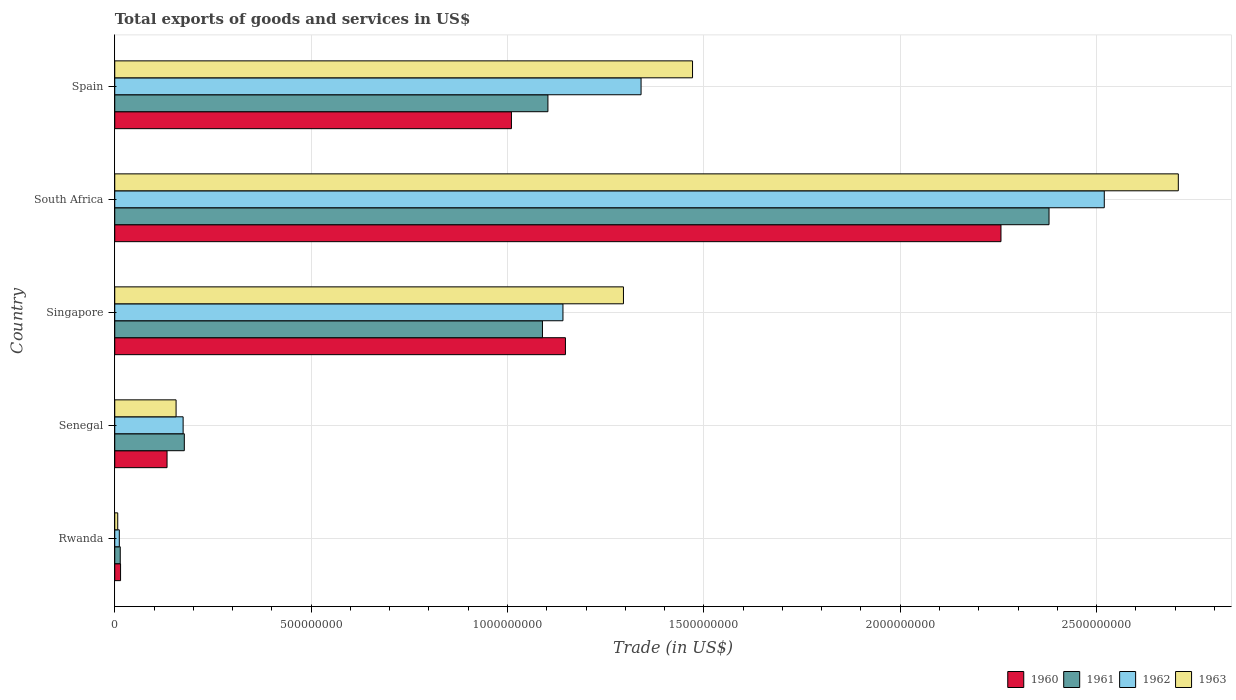How many bars are there on the 3rd tick from the top?
Give a very brief answer. 4. How many bars are there on the 1st tick from the bottom?
Provide a short and direct response. 4. What is the label of the 5th group of bars from the top?
Offer a terse response. Rwanda. What is the total exports of goods and services in 1960 in Rwanda?
Your response must be concise. 1.48e+07. Across all countries, what is the maximum total exports of goods and services in 1963?
Keep it short and to the point. 2.71e+09. Across all countries, what is the minimum total exports of goods and services in 1960?
Ensure brevity in your answer.  1.48e+07. In which country was the total exports of goods and services in 1962 maximum?
Your response must be concise. South Africa. In which country was the total exports of goods and services in 1963 minimum?
Offer a very short reply. Rwanda. What is the total total exports of goods and services in 1963 in the graph?
Provide a succinct answer. 5.64e+09. What is the difference between the total exports of goods and services in 1962 in Senegal and that in Spain?
Ensure brevity in your answer.  -1.17e+09. What is the difference between the total exports of goods and services in 1962 in Rwanda and the total exports of goods and services in 1960 in South Africa?
Ensure brevity in your answer.  -2.24e+09. What is the average total exports of goods and services in 1963 per country?
Give a very brief answer. 1.13e+09. What is the difference between the total exports of goods and services in 1960 and total exports of goods and services in 1962 in Spain?
Your response must be concise. -3.30e+08. In how many countries, is the total exports of goods and services in 1963 greater than 2600000000 US$?
Keep it short and to the point. 1. What is the ratio of the total exports of goods and services in 1962 in Singapore to that in Spain?
Your answer should be compact. 0.85. Is the total exports of goods and services in 1960 in Singapore less than that in South Africa?
Give a very brief answer. Yes. What is the difference between the highest and the second highest total exports of goods and services in 1962?
Ensure brevity in your answer.  1.18e+09. What is the difference between the highest and the lowest total exports of goods and services in 1963?
Keep it short and to the point. 2.70e+09. Is the sum of the total exports of goods and services in 1961 in Senegal and Spain greater than the maximum total exports of goods and services in 1960 across all countries?
Your response must be concise. No. Is it the case that in every country, the sum of the total exports of goods and services in 1962 and total exports of goods and services in 1960 is greater than the sum of total exports of goods and services in 1961 and total exports of goods and services in 1963?
Your answer should be very brief. No. What does the 4th bar from the top in Senegal represents?
Give a very brief answer. 1960. How many bars are there?
Your answer should be compact. 20. How many countries are there in the graph?
Your response must be concise. 5. What is the difference between two consecutive major ticks on the X-axis?
Your answer should be compact. 5.00e+08. Does the graph contain any zero values?
Make the answer very short. No. Where does the legend appear in the graph?
Provide a short and direct response. Bottom right. How many legend labels are there?
Offer a terse response. 4. What is the title of the graph?
Make the answer very short. Total exports of goods and services in US$. Does "1990" appear as one of the legend labels in the graph?
Offer a very short reply. No. What is the label or title of the X-axis?
Give a very brief answer. Trade (in US$). What is the label or title of the Y-axis?
Make the answer very short. Country. What is the Trade (in US$) of 1960 in Rwanda?
Your response must be concise. 1.48e+07. What is the Trade (in US$) in 1961 in Rwanda?
Your answer should be very brief. 1.40e+07. What is the Trade (in US$) in 1962 in Rwanda?
Offer a terse response. 1.16e+07. What is the Trade (in US$) in 1963 in Rwanda?
Offer a very short reply. 7.60e+06. What is the Trade (in US$) of 1960 in Senegal?
Give a very brief answer. 1.33e+08. What is the Trade (in US$) in 1961 in Senegal?
Offer a very short reply. 1.77e+08. What is the Trade (in US$) of 1962 in Senegal?
Keep it short and to the point. 1.74e+08. What is the Trade (in US$) in 1963 in Senegal?
Offer a very short reply. 1.56e+08. What is the Trade (in US$) in 1960 in Singapore?
Your answer should be very brief. 1.15e+09. What is the Trade (in US$) in 1961 in Singapore?
Your response must be concise. 1.09e+09. What is the Trade (in US$) in 1962 in Singapore?
Provide a succinct answer. 1.14e+09. What is the Trade (in US$) in 1963 in Singapore?
Keep it short and to the point. 1.30e+09. What is the Trade (in US$) in 1960 in South Africa?
Keep it short and to the point. 2.26e+09. What is the Trade (in US$) of 1961 in South Africa?
Ensure brevity in your answer.  2.38e+09. What is the Trade (in US$) in 1962 in South Africa?
Provide a succinct answer. 2.52e+09. What is the Trade (in US$) of 1963 in South Africa?
Keep it short and to the point. 2.71e+09. What is the Trade (in US$) of 1960 in Spain?
Your answer should be compact. 1.01e+09. What is the Trade (in US$) of 1961 in Spain?
Provide a succinct answer. 1.10e+09. What is the Trade (in US$) in 1962 in Spain?
Offer a very short reply. 1.34e+09. What is the Trade (in US$) in 1963 in Spain?
Make the answer very short. 1.47e+09. Across all countries, what is the maximum Trade (in US$) in 1960?
Offer a very short reply. 2.26e+09. Across all countries, what is the maximum Trade (in US$) in 1961?
Ensure brevity in your answer.  2.38e+09. Across all countries, what is the maximum Trade (in US$) in 1962?
Give a very brief answer. 2.52e+09. Across all countries, what is the maximum Trade (in US$) of 1963?
Provide a succinct answer. 2.71e+09. Across all countries, what is the minimum Trade (in US$) in 1960?
Ensure brevity in your answer.  1.48e+07. Across all countries, what is the minimum Trade (in US$) of 1961?
Provide a succinct answer. 1.40e+07. Across all countries, what is the minimum Trade (in US$) in 1962?
Your response must be concise. 1.16e+07. Across all countries, what is the minimum Trade (in US$) in 1963?
Offer a terse response. 7.60e+06. What is the total Trade (in US$) in 1960 in the graph?
Your response must be concise. 4.56e+09. What is the total Trade (in US$) in 1961 in the graph?
Your response must be concise. 4.76e+09. What is the total Trade (in US$) of 1962 in the graph?
Offer a very short reply. 5.19e+09. What is the total Trade (in US$) in 1963 in the graph?
Your answer should be very brief. 5.64e+09. What is the difference between the Trade (in US$) in 1960 in Rwanda and that in Senegal?
Your response must be concise. -1.18e+08. What is the difference between the Trade (in US$) of 1961 in Rwanda and that in Senegal?
Make the answer very short. -1.63e+08. What is the difference between the Trade (in US$) of 1962 in Rwanda and that in Senegal?
Your answer should be very brief. -1.62e+08. What is the difference between the Trade (in US$) in 1963 in Rwanda and that in Senegal?
Provide a succinct answer. -1.49e+08. What is the difference between the Trade (in US$) of 1960 in Rwanda and that in Singapore?
Provide a short and direct response. -1.13e+09. What is the difference between the Trade (in US$) of 1961 in Rwanda and that in Singapore?
Offer a terse response. -1.08e+09. What is the difference between the Trade (in US$) in 1962 in Rwanda and that in Singapore?
Make the answer very short. -1.13e+09. What is the difference between the Trade (in US$) of 1963 in Rwanda and that in Singapore?
Make the answer very short. -1.29e+09. What is the difference between the Trade (in US$) in 1960 in Rwanda and that in South Africa?
Provide a succinct answer. -2.24e+09. What is the difference between the Trade (in US$) in 1961 in Rwanda and that in South Africa?
Ensure brevity in your answer.  -2.36e+09. What is the difference between the Trade (in US$) of 1962 in Rwanda and that in South Africa?
Provide a short and direct response. -2.51e+09. What is the difference between the Trade (in US$) of 1963 in Rwanda and that in South Africa?
Provide a short and direct response. -2.70e+09. What is the difference between the Trade (in US$) of 1960 in Rwanda and that in Spain?
Ensure brevity in your answer.  -9.95e+08. What is the difference between the Trade (in US$) in 1961 in Rwanda and that in Spain?
Provide a short and direct response. -1.09e+09. What is the difference between the Trade (in US$) in 1962 in Rwanda and that in Spain?
Provide a succinct answer. -1.33e+09. What is the difference between the Trade (in US$) in 1963 in Rwanda and that in Spain?
Make the answer very short. -1.46e+09. What is the difference between the Trade (in US$) of 1960 in Senegal and that in Singapore?
Offer a very short reply. -1.01e+09. What is the difference between the Trade (in US$) of 1961 in Senegal and that in Singapore?
Ensure brevity in your answer.  -9.12e+08. What is the difference between the Trade (in US$) of 1962 in Senegal and that in Singapore?
Your response must be concise. -9.67e+08. What is the difference between the Trade (in US$) of 1963 in Senegal and that in Singapore?
Keep it short and to the point. -1.14e+09. What is the difference between the Trade (in US$) in 1960 in Senegal and that in South Africa?
Give a very brief answer. -2.12e+09. What is the difference between the Trade (in US$) in 1961 in Senegal and that in South Africa?
Your answer should be very brief. -2.20e+09. What is the difference between the Trade (in US$) of 1962 in Senegal and that in South Africa?
Provide a short and direct response. -2.35e+09. What is the difference between the Trade (in US$) of 1963 in Senegal and that in South Africa?
Offer a very short reply. -2.55e+09. What is the difference between the Trade (in US$) in 1960 in Senegal and that in Spain?
Make the answer very short. -8.77e+08. What is the difference between the Trade (in US$) of 1961 in Senegal and that in Spain?
Make the answer very short. -9.26e+08. What is the difference between the Trade (in US$) of 1962 in Senegal and that in Spain?
Offer a terse response. -1.17e+09. What is the difference between the Trade (in US$) in 1963 in Senegal and that in Spain?
Make the answer very short. -1.31e+09. What is the difference between the Trade (in US$) in 1960 in Singapore and that in South Africa?
Your answer should be very brief. -1.11e+09. What is the difference between the Trade (in US$) in 1961 in Singapore and that in South Africa?
Ensure brevity in your answer.  -1.29e+09. What is the difference between the Trade (in US$) in 1962 in Singapore and that in South Africa?
Ensure brevity in your answer.  -1.38e+09. What is the difference between the Trade (in US$) of 1963 in Singapore and that in South Africa?
Provide a short and direct response. -1.41e+09. What is the difference between the Trade (in US$) of 1960 in Singapore and that in Spain?
Keep it short and to the point. 1.37e+08. What is the difference between the Trade (in US$) in 1961 in Singapore and that in Spain?
Give a very brief answer. -1.39e+07. What is the difference between the Trade (in US$) in 1962 in Singapore and that in Spain?
Ensure brevity in your answer.  -1.99e+08. What is the difference between the Trade (in US$) in 1963 in Singapore and that in Spain?
Ensure brevity in your answer.  -1.76e+08. What is the difference between the Trade (in US$) of 1960 in South Africa and that in Spain?
Your answer should be very brief. 1.25e+09. What is the difference between the Trade (in US$) in 1961 in South Africa and that in Spain?
Make the answer very short. 1.28e+09. What is the difference between the Trade (in US$) in 1962 in South Africa and that in Spain?
Your answer should be very brief. 1.18e+09. What is the difference between the Trade (in US$) in 1963 in South Africa and that in Spain?
Make the answer very short. 1.24e+09. What is the difference between the Trade (in US$) in 1960 in Rwanda and the Trade (in US$) in 1961 in Senegal?
Give a very brief answer. -1.62e+08. What is the difference between the Trade (in US$) of 1960 in Rwanda and the Trade (in US$) of 1962 in Senegal?
Ensure brevity in your answer.  -1.59e+08. What is the difference between the Trade (in US$) in 1960 in Rwanda and the Trade (in US$) in 1963 in Senegal?
Offer a very short reply. -1.41e+08. What is the difference between the Trade (in US$) in 1961 in Rwanda and the Trade (in US$) in 1962 in Senegal?
Your answer should be very brief. -1.60e+08. What is the difference between the Trade (in US$) in 1961 in Rwanda and the Trade (in US$) in 1963 in Senegal?
Give a very brief answer. -1.42e+08. What is the difference between the Trade (in US$) in 1962 in Rwanda and the Trade (in US$) in 1963 in Senegal?
Provide a short and direct response. -1.45e+08. What is the difference between the Trade (in US$) of 1960 in Rwanda and the Trade (in US$) of 1961 in Singapore?
Make the answer very short. -1.07e+09. What is the difference between the Trade (in US$) of 1960 in Rwanda and the Trade (in US$) of 1962 in Singapore?
Your answer should be very brief. -1.13e+09. What is the difference between the Trade (in US$) of 1960 in Rwanda and the Trade (in US$) of 1963 in Singapore?
Provide a succinct answer. -1.28e+09. What is the difference between the Trade (in US$) of 1961 in Rwanda and the Trade (in US$) of 1962 in Singapore?
Your answer should be very brief. -1.13e+09. What is the difference between the Trade (in US$) of 1961 in Rwanda and the Trade (in US$) of 1963 in Singapore?
Provide a succinct answer. -1.28e+09. What is the difference between the Trade (in US$) of 1962 in Rwanda and the Trade (in US$) of 1963 in Singapore?
Offer a very short reply. -1.28e+09. What is the difference between the Trade (in US$) in 1960 in Rwanda and the Trade (in US$) in 1961 in South Africa?
Your answer should be very brief. -2.36e+09. What is the difference between the Trade (in US$) of 1960 in Rwanda and the Trade (in US$) of 1962 in South Africa?
Your answer should be very brief. -2.50e+09. What is the difference between the Trade (in US$) of 1960 in Rwanda and the Trade (in US$) of 1963 in South Africa?
Offer a terse response. -2.69e+09. What is the difference between the Trade (in US$) of 1961 in Rwanda and the Trade (in US$) of 1962 in South Africa?
Make the answer very short. -2.51e+09. What is the difference between the Trade (in US$) in 1961 in Rwanda and the Trade (in US$) in 1963 in South Africa?
Keep it short and to the point. -2.69e+09. What is the difference between the Trade (in US$) of 1962 in Rwanda and the Trade (in US$) of 1963 in South Africa?
Make the answer very short. -2.70e+09. What is the difference between the Trade (in US$) in 1960 in Rwanda and the Trade (in US$) in 1961 in Spain?
Your answer should be compact. -1.09e+09. What is the difference between the Trade (in US$) of 1960 in Rwanda and the Trade (in US$) of 1962 in Spain?
Offer a terse response. -1.33e+09. What is the difference between the Trade (in US$) of 1960 in Rwanda and the Trade (in US$) of 1963 in Spain?
Your response must be concise. -1.46e+09. What is the difference between the Trade (in US$) of 1961 in Rwanda and the Trade (in US$) of 1962 in Spain?
Give a very brief answer. -1.33e+09. What is the difference between the Trade (in US$) in 1961 in Rwanda and the Trade (in US$) in 1963 in Spain?
Give a very brief answer. -1.46e+09. What is the difference between the Trade (in US$) of 1962 in Rwanda and the Trade (in US$) of 1963 in Spain?
Your response must be concise. -1.46e+09. What is the difference between the Trade (in US$) of 1960 in Senegal and the Trade (in US$) of 1961 in Singapore?
Your response must be concise. -9.56e+08. What is the difference between the Trade (in US$) in 1960 in Senegal and the Trade (in US$) in 1962 in Singapore?
Your response must be concise. -1.01e+09. What is the difference between the Trade (in US$) of 1960 in Senegal and the Trade (in US$) of 1963 in Singapore?
Your answer should be very brief. -1.16e+09. What is the difference between the Trade (in US$) of 1961 in Senegal and the Trade (in US$) of 1962 in Singapore?
Ensure brevity in your answer.  -9.64e+08. What is the difference between the Trade (in US$) in 1961 in Senegal and the Trade (in US$) in 1963 in Singapore?
Your response must be concise. -1.12e+09. What is the difference between the Trade (in US$) of 1962 in Senegal and the Trade (in US$) of 1963 in Singapore?
Provide a short and direct response. -1.12e+09. What is the difference between the Trade (in US$) in 1960 in Senegal and the Trade (in US$) in 1961 in South Africa?
Provide a succinct answer. -2.25e+09. What is the difference between the Trade (in US$) of 1960 in Senegal and the Trade (in US$) of 1962 in South Africa?
Give a very brief answer. -2.39e+09. What is the difference between the Trade (in US$) in 1960 in Senegal and the Trade (in US$) in 1963 in South Africa?
Provide a short and direct response. -2.57e+09. What is the difference between the Trade (in US$) in 1961 in Senegal and the Trade (in US$) in 1962 in South Africa?
Offer a terse response. -2.34e+09. What is the difference between the Trade (in US$) in 1961 in Senegal and the Trade (in US$) in 1963 in South Africa?
Your answer should be very brief. -2.53e+09. What is the difference between the Trade (in US$) in 1962 in Senegal and the Trade (in US$) in 1963 in South Africa?
Make the answer very short. -2.53e+09. What is the difference between the Trade (in US$) in 1960 in Senegal and the Trade (in US$) in 1961 in Spain?
Ensure brevity in your answer.  -9.70e+08. What is the difference between the Trade (in US$) in 1960 in Senegal and the Trade (in US$) in 1962 in Spain?
Make the answer very short. -1.21e+09. What is the difference between the Trade (in US$) of 1960 in Senegal and the Trade (in US$) of 1963 in Spain?
Your answer should be compact. -1.34e+09. What is the difference between the Trade (in US$) of 1961 in Senegal and the Trade (in US$) of 1962 in Spain?
Your answer should be very brief. -1.16e+09. What is the difference between the Trade (in US$) in 1961 in Senegal and the Trade (in US$) in 1963 in Spain?
Your response must be concise. -1.29e+09. What is the difference between the Trade (in US$) of 1962 in Senegal and the Trade (in US$) of 1963 in Spain?
Offer a terse response. -1.30e+09. What is the difference between the Trade (in US$) in 1960 in Singapore and the Trade (in US$) in 1961 in South Africa?
Offer a terse response. -1.23e+09. What is the difference between the Trade (in US$) in 1960 in Singapore and the Trade (in US$) in 1962 in South Africa?
Your answer should be compact. -1.37e+09. What is the difference between the Trade (in US$) of 1960 in Singapore and the Trade (in US$) of 1963 in South Africa?
Give a very brief answer. -1.56e+09. What is the difference between the Trade (in US$) of 1961 in Singapore and the Trade (in US$) of 1962 in South Africa?
Offer a very short reply. -1.43e+09. What is the difference between the Trade (in US$) of 1961 in Singapore and the Trade (in US$) of 1963 in South Africa?
Make the answer very short. -1.62e+09. What is the difference between the Trade (in US$) in 1962 in Singapore and the Trade (in US$) in 1963 in South Africa?
Provide a succinct answer. -1.57e+09. What is the difference between the Trade (in US$) in 1960 in Singapore and the Trade (in US$) in 1961 in Spain?
Provide a succinct answer. 4.46e+07. What is the difference between the Trade (in US$) of 1960 in Singapore and the Trade (in US$) of 1962 in Spain?
Your answer should be very brief. -1.93e+08. What is the difference between the Trade (in US$) in 1960 in Singapore and the Trade (in US$) in 1963 in Spain?
Offer a terse response. -3.24e+08. What is the difference between the Trade (in US$) in 1961 in Singapore and the Trade (in US$) in 1962 in Spain?
Your answer should be compact. -2.51e+08. What is the difference between the Trade (in US$) in 1961 in Singapore and the Trade (in US$) in 1963 in Spain?
Your response must be concise. -3.82e+08. What is the difference between the Trade (in US$) in 1962 in Singapore and the Trade (in US$) in 1963 in Spain?
Your answer should be compact. -3.30e+08. What is the difference between the Trade (in US$) in 1960 in South Africa and the Trade (in US$) in 1961 in Spain?
Your answer should be compact. 1.15e+09. What is the difference between the Trade (in US$) of 1960 in South Africa and the Trade (in US$) of 1962 in Spain?
Your answer should be very brief. 9.16e+08. What is the difference between the Trade (in US$) of 1960 in South Africa and the Trade (in US$) of 1963 in Spain?
Provide a short and direct response. 7.85e+08. What is the difference between the Trade (in US$) in 1961 in South Africa and the Trade (in US$) in 1962 in Spain?
Offer a terse response. 1.04e+09. What is the difference between the Trade (in US$) in 1961 in South Africa and the Trade (in US$) in 1963 in Spain?
Offer a very short reply. 9.08e+08. What is the difference between the Trade (in US$) in 1962 in South Africa and the Trade (in US$) in 1963 in Spain?
Offer a very short reply. 1.05e+09. What is the average Trade (in US$) in 1960 per country?
Make the answer very short. 9.12e+08. What is the average Trade (in US$) in 1961 per country?
Your answer should be compact. 9.52e+08. What is the average Trade (in US$) in 1962 per country?
Offer a terse response. 1.04e+09. What is the average Trade (in US$) in 1963 per country?
Offer a terse response. 1.13e+09. What is the difference between the Trade (in US$) in 1960 and Trade (in US$) in 1961 in Rwanda?
Offer a very short reply. 8.00e+05. What is the difference between the Trade (in US$) in 1960 and Trade (in US$) in 1962 in Rwanda?
Offer a terse response. 3.20e+06. What is the difference between the Trade (in US$) in 1960 and Trade (in US$) in 1963 in Rwanda?
Make the answer very short. 7.20e+06. What is the difference between the Trade (in US$) in 1961 and Trade (in US$) in 1962 in Rwanda?
Make the answer very short. 2.40e+06. What is the difference between the Trade (in US$) of 1961 and Trade (in US$) of 1963 in Rwanda?
Provide a short and direct response. 6.40e+06. What is the difference between the Trade (in US$) of 1962 and Trade (in US$) of 1963 in Rwanda?
Keep it short and to the point. 4.00e+06. What is the difference between the Trade (in US$) in 1960 and Trade (in US$) in 1961 in Senegal?
Offer a terse response. -4.40e+07. What is the difference between the Trade (in US$) of 1960 and Trade (in US$) of 1962 in Senegal?
Provide a short and direct response. -4.09e+07. What is the difference between the Trade (in US$) in 1960 and Trade (in US$) in 1963 in Senegal?
Provide a succinct answer. -2.30e+07. What is the difference between the Trade (in US$) in 1961 and Trade (in US$) in 1962 in Senegal?
Make the answer very short. 3.05e+06. What is the difference between the Trade (in US$) of 1961 and Trade (in US$) of 1963 in Senegal?
Your answer should be compact. 2.10e+07. What is the difference between the Trade (in US$) of 1962 and Trade (in US$) of 1963 in Senegal?
Offer a very short reply. 1.79e+07. What is the difference between the Trade (in US$) in 1960 and Trade (in US$) in 1961 in Singapore?
Provide a succinct answer. 5.85e+07. What is the difference between the Trade (in US$) of 1960 and Trade (in US$) of 1962 in Singapore?
Make the answer very short. 6.30e+06. What is the difference between the Trade (in US$) of 1960 and Trade (in US$) of 1963 in Singapore?
Your response must be concise. -1.48e+08. What is the difference between the Trade (in US$) of 1961 and Trade (in US$) of 1962 in Singapore?
Your answer should be compact. -5.22e+07. What is the difference between the Trade (in US$) in 1961 and Trade (in US$) in 1963 in Singapore?
Keep it short and to the point. -2.06e+08. What is the difference between the Trade (in US$) in 1962 and Trade (in US$) in 1963 in Singapore?
Your response must be concise. -1.54e+08. What is the difference between the Trade (in US$) of 1960 and Trade (in US$) of 1961 in South Africa?
Your answer should be very brief. -1.22e+08. What is the difference between the Trade (in US$) of 1960 and Trade (in US$) of 1962 in South Africa?
Provide a succinct answer. -2.63e+08. What is the difference between the Trade (in US$) of 1960 and Trade (in US$) of 1963 in South Africa?
Offer a terse response. -4.52e+08. What is the difference between the Trade (in US$) of 1961 and Trade (in US$) of 1962 in South Africa?
Provide a short and direct response. -1.41e+08. What is the difference between the Trade (in US$) of 1961 and Trade (in US$) of 1963 in South Africa?
Ensure brevity in your answer.  -3.29e+08. What is the difference between the Trade (in US$) in 1962 and Trade (in US$) in 1963 in South Africa?
Provide a short and direct response. -1.89e+08. What is the difference between the Trade (in US$) in 1960 and Trade (in US$) in 1961 in Spain?
Provide a short and direct response. -9.29e+07. What is the difference between the Trade (in US$) of 1960 and Trade (in US$) of 1962 in Spain?
Ensure brevity in your answer.  -3.30e+08. What is the difference between the Trade (in US$) in 1960 and Trade (in US$) in 1963 in Spain?
Give a very brief answer. -4.61e+08. What is the difference between the Trade (in US$) of 1961 and Trade (in US$) of 1962 in Spain?
Your answer should be very brief. -2.37e+08. What is the difference between the Trade (in US$) in 1961 and Trade (in US$) in 1963 in Spain?
Your answer should be very brief. -3.68e+08. What is the difference between the Trade (in US$) in 1962 and Trade (in US$) in 1963 in Spain?
Offer a terse response. -1.31e+08. What is the ratio of the Trade (in US$) in 1960 in Rwanda to that in Senegal?
Offer a terse response. 0.11. What is the ratio of the Trade (in US$) of 1961 in Rwanda to that in Senegal?
Your answer should be compact. 0.08. What is the ratio of the Trade (in US$) in 1962 in Rwanda to that in Senegal?
Provide a short and direct response. 0.07. What is the ratio of the Trade (in US$) of 1963 in Rwanda to that in Senegal?
Your answer should be very brief. 0.05. What is the ratio of the Trade (in US$) in 1960 in Rwanda to that in Singapore?
Offer a terse response. 0.01. What is the ratio of the Trade (in US$) of 1961 in Rwanda to that in Singapore?
Ensure brevity in your answer.  0.01. What is the ratio of the Trade (in US$) in 1962 in Rwanda to that in Singapore?
Ensure brevity in your answer.  0.01. What is the ratio of the Trade (in US$) of 1963 in Rwanda to that in Singapore?
Your response must be concise. 0.01. What is the ratio of the Trade (in US$) of 1960 in Rwanda to that in South Africa?
Your answer should be very brief. 0.01. What is the ratio of the Trade (in US$) in 1961 in Rwanda to that in South Africa?
Ensure brevity in your answer.  0.01. What is the ratio of the Trade (in US$) of 1962 in Rwanda to that in South Africa?
Offer a terse response. 0. What is the ratio of the Trade (in US$) in 1963 in Rwanda to that in South Africa?
Your answer should be very brief. 0. What is the ratio of the Trade (in US$) of 1960 in Rwanda to that in Spain?
Your answer should be very brief. 0.01. What is the ratio of the Trade (in US$) of 1961 in Rwanda to that in Spain?
Give a very brief answer. 0.01. What is the ratio of the Trade (in US$) in 1962 in Rwanda to that in Spain?
Your answer should be very brief. 0.01. What is the ratio of the Trade (in US$) of 1963 in Rwanda to that in Spain?
Offer a very short reply. 0.01. What is the ratio of the Trade (in US$) in 1960 in Senegal to that in Singapore?
Your answer should be compact. 0.12. What is the ratio of the Trade (in US$) of 1961 in Senegal to that in Singapore?
Your answer should be compact. 0.16. What is the ratio of the Trade (in US$) in 1962 in Senegal to that in Singapore?
Offer a terse response. 0.15. What is the ratio of the Trade (in US$) in 1963 in Senegal to that in Singapore?
Keep it short and to the point. 0.12. What is the ratio of the Trade (in US$) of 1960 in Senegal to that in South Africa?
Give a very brief answer. 0.06. What is the ratio of the Trade (in US$) of 1961 in Senegal to that in South Africa?
Your response must be concise. 0.07. What is the ratio of the Trade (in US$) of 1962 in Senegal to that in South Africa?
Your response must be concise. 0.07. What is the ratio of the Trade (in US$) in 1963 in Senegal to that in South Africa?
Your response must be concise. 0.06. What is the ratio of the Trade (in US$) of 1960 in Senegal to that in Spain?
Provide a succinct answer. 0.13. What is the ratio of the Trade (in US$) of 1961 in Senegal to that in Spain?
Your answer should be very brief. 0.16. What is the ratio of the Trade (in US$) of 1962 in Senegal to that in Spain?
Your answer should be very brief. 0.13. What is the ratio of the Trade (in US$) of 1963 in Senegal to that in Spain?
Give a very brief answer. 0.11. What is the ratio of the Trade (in US$) of 1960 in Singapore to that in South Africa?
Your answer should be very brief. 0.51. What is the ratio of the Trade (in US$) in 1961 in Singapore to that in South Africa?
Your response must be concise. 0.46. What is the ratio of the Trade (in US$) of 1962 in Singapore to that in South Africa?
Ensure brevity in your answer.  0.45. What is the ratio of the Trade (in US$) of 1963 in Singapore to that in South Africa?
Provide a short and direct response. 0.48. What is the ratio of the Trade (in US$) in 1960 in Singapore to that in Spain?
Offer a terse response. 1.14. What is the ratio of the Trade (in US$) in 1961 in Singapore to that in Spain?
Your answer should be compact. 0.99. What is the ratio of the Trade (in US$) of 1962 in Singapore to that in Spain?
Your answer should be compact. 0.85. What is the ratio of the Trade (in US$) in 1963 in Singapore to that in Spain?
Provide a succinct answer. 0.88. What is the ratio of the Trade (in US$) in 1960 in South Africa to that in Spain?
Your answer should be very brief. 2.23. What is the ratio of the Trade (in US$) of 1961 in South Africa to that in Spain?
Make the answer very short. 2.16. What is the ratio of the Trade (in US$) in 1962 in South Africa to that in Spain?
Make the answer very short. 1.88. What is the ratio of the Trade (in US$) in 1963 in South Africa to that in Spain?
Offer a very short reply. 1.84. What is the difference between the highest and the second highest Trade (in US$) in 1960?
Offer a very short reply. 1.11e+09. What is the difference between the highest and the second highest Trade (in US$) in 1961?
Your answer should be very brief. 1.28e+09. What is the difference between the highest and the second highest Trade (in US$) of 1962?
Give a very brief answer. 1.18e+09. What is the difference between the highest and the second highest Trade (in US$) in 1963?
Keep it short and to the point. 1.24e+09. What is the difference between the highest and the lowest Trade (in US$) of 1960?
Ensure brevity in your answer.  2.24e+09. What is the difference between the highest and the lowest Trade (in US$) in 1961?
Your answer should be compact. 2.36e+09. What is the difference between the highest and the lowest Trade (in US$) of 1962?
Offer a very short reply. 2.51e+09. What is the difference between the highest and the lowest Trade (in US$) of 1963?
Give a very brief answer. 2.70e+09. 